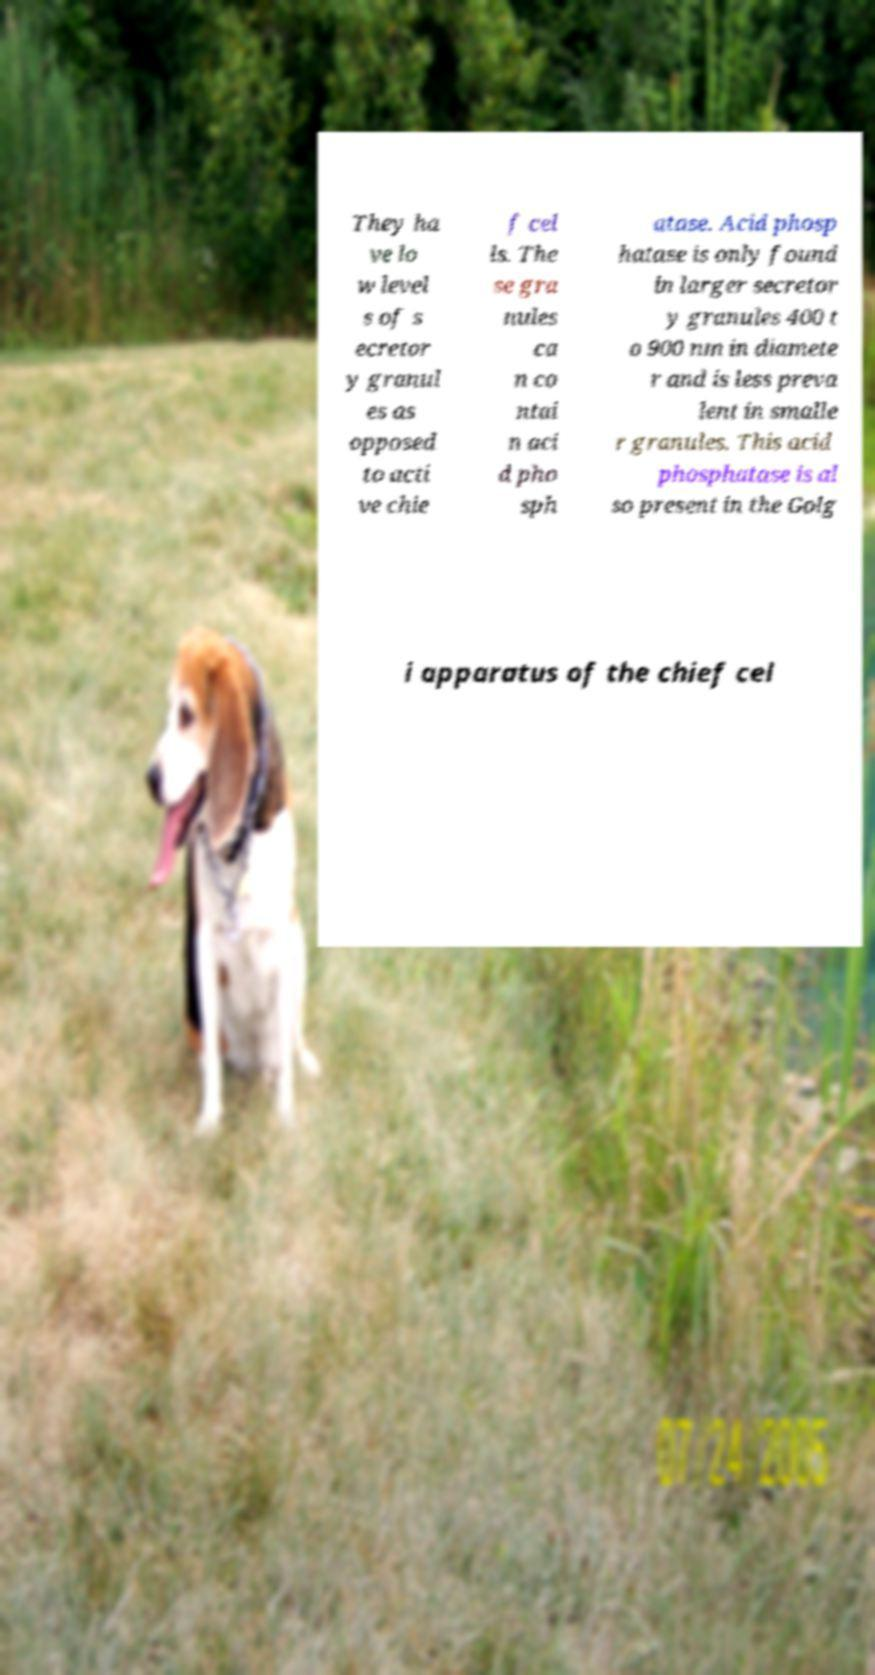For documentation purposes, I need the text within this image transcribed. Could you provide that? They ha ve lo w level s of s ecretor y granul es as opposed to acti ve chie f cel ls. The se gra nules ca n co ntai n aci d pho sph atase. Acid phosp hatase is only found in larger secretor y granules 400 t o 900 nm in diamete r and is less preva lent in smalle r granules. This acid phosphatase is al so present in the Golg i apparatus of the chief cel 